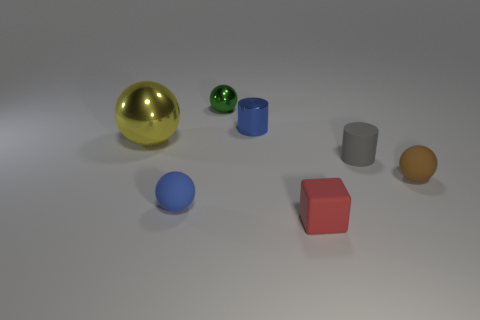Add 3 small blocks. How many objects exist? 10 Subtract all gray spheres. Subtract all brown cubes. How many spheres are left? 4 Subtract all blocks. How many objects are left? 6 Subtract all metal cubes. Subtract all tiny red rubber cubes. How many objects are left? 6 Add 7 gray matte things. How many gray matte things are left? 8 Add 6 gray rubber things. How many gray rubber things exist? 7 Subtract 1 green balls. How many objects are left? 6 